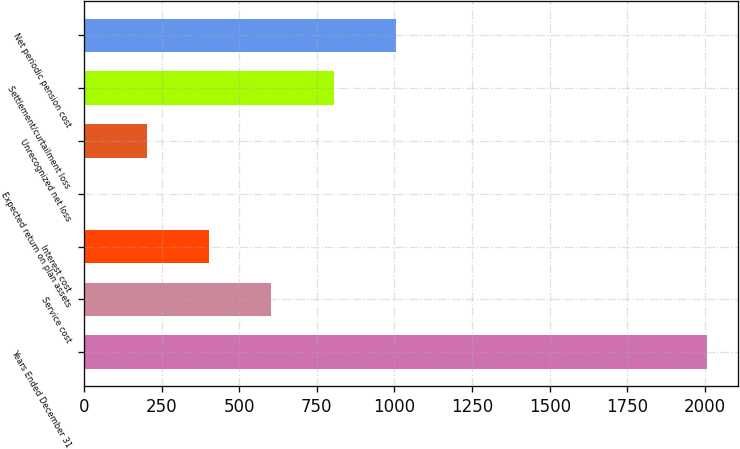Convert chart. <chart><loc_0><loc_0><loc_500><loc_500><bar_chart><fcel>Years Ended December 31<fcel>Service cost<fcel>Interest cost<fcel>Expected return on plan assets<fcel>Unrecognized net loss<fcel>Settlement/curtailment loss<fcel>Net periodic pension cost<nl><fcel>2005<fcel>603.6<fcel>403.4<fcel>3<fcel>203.2<fcel>803.8<fcel>1004<nl></chart> 